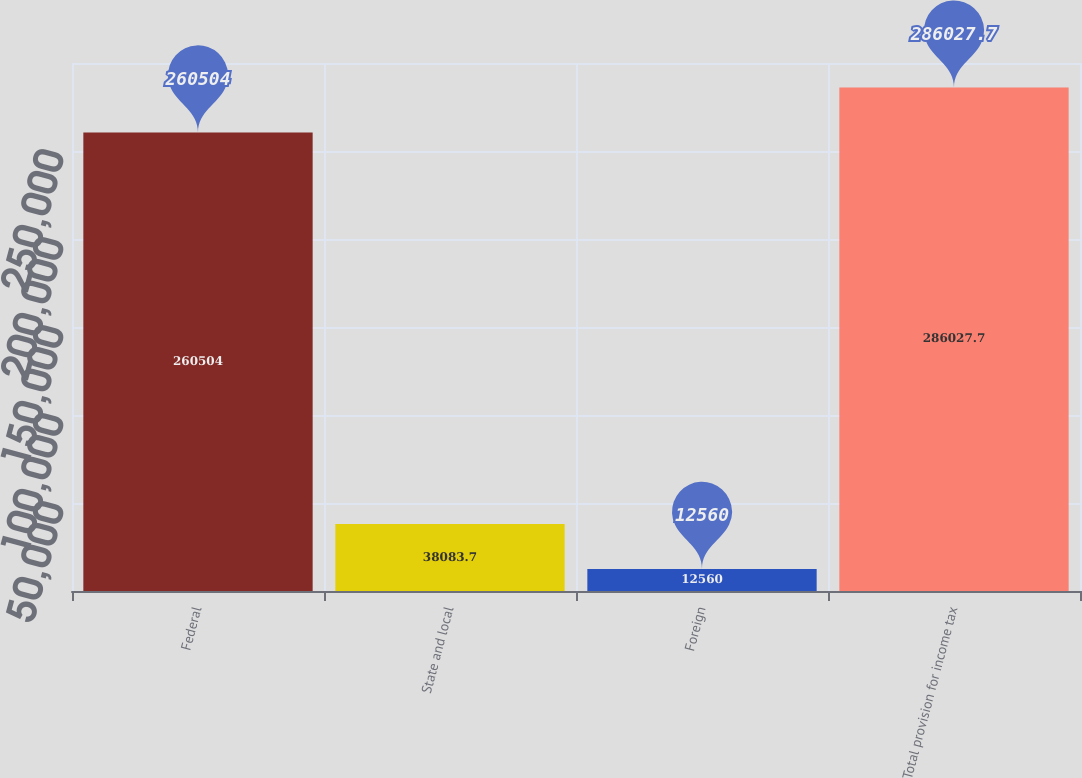Convert chart to OTSL. <chart><loc_0><loc_0><loc_500><loc_500><bar_chart><fcel>Federal<fcel>State and local<fcel>Foreign<fcel>Total provision for income tax<nl><fcel>260504<fcel>38083.7<fcel>12560<fcel>286028<nl></chart> 